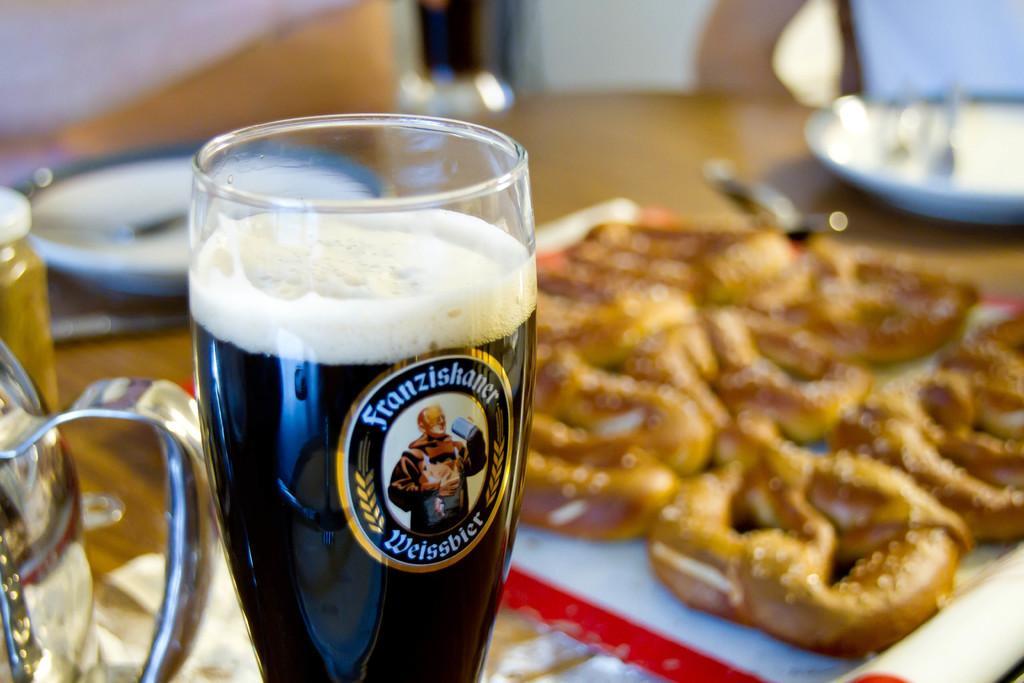Can you describe this image briefly? In this image I can see a glass,food items,plates,spoons and few objects on the brown table. Food is brown color. 